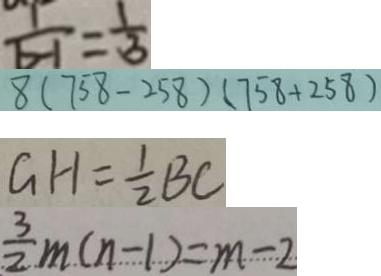<formula> <loc_0><loc_0><loc_500><loc_500>\frac { 1 } { b - 1 } = \frac { 1 } { 3 } 
 8 ( 7 5 8 - 2 5 8 ) ( 7 5 8 + 2 5 8 ) 
 G H = \frac { 1 } { 2 } B C 
 \frac { 3 } { 2 } m ( n - 1 ) = m - 2</formula> 